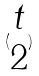Convert formula to latex. <formula><loc_0><loc_0><loc_500><loc_500>( \begin{matrix} t \\ 2 \end{matrix} )</formula> 